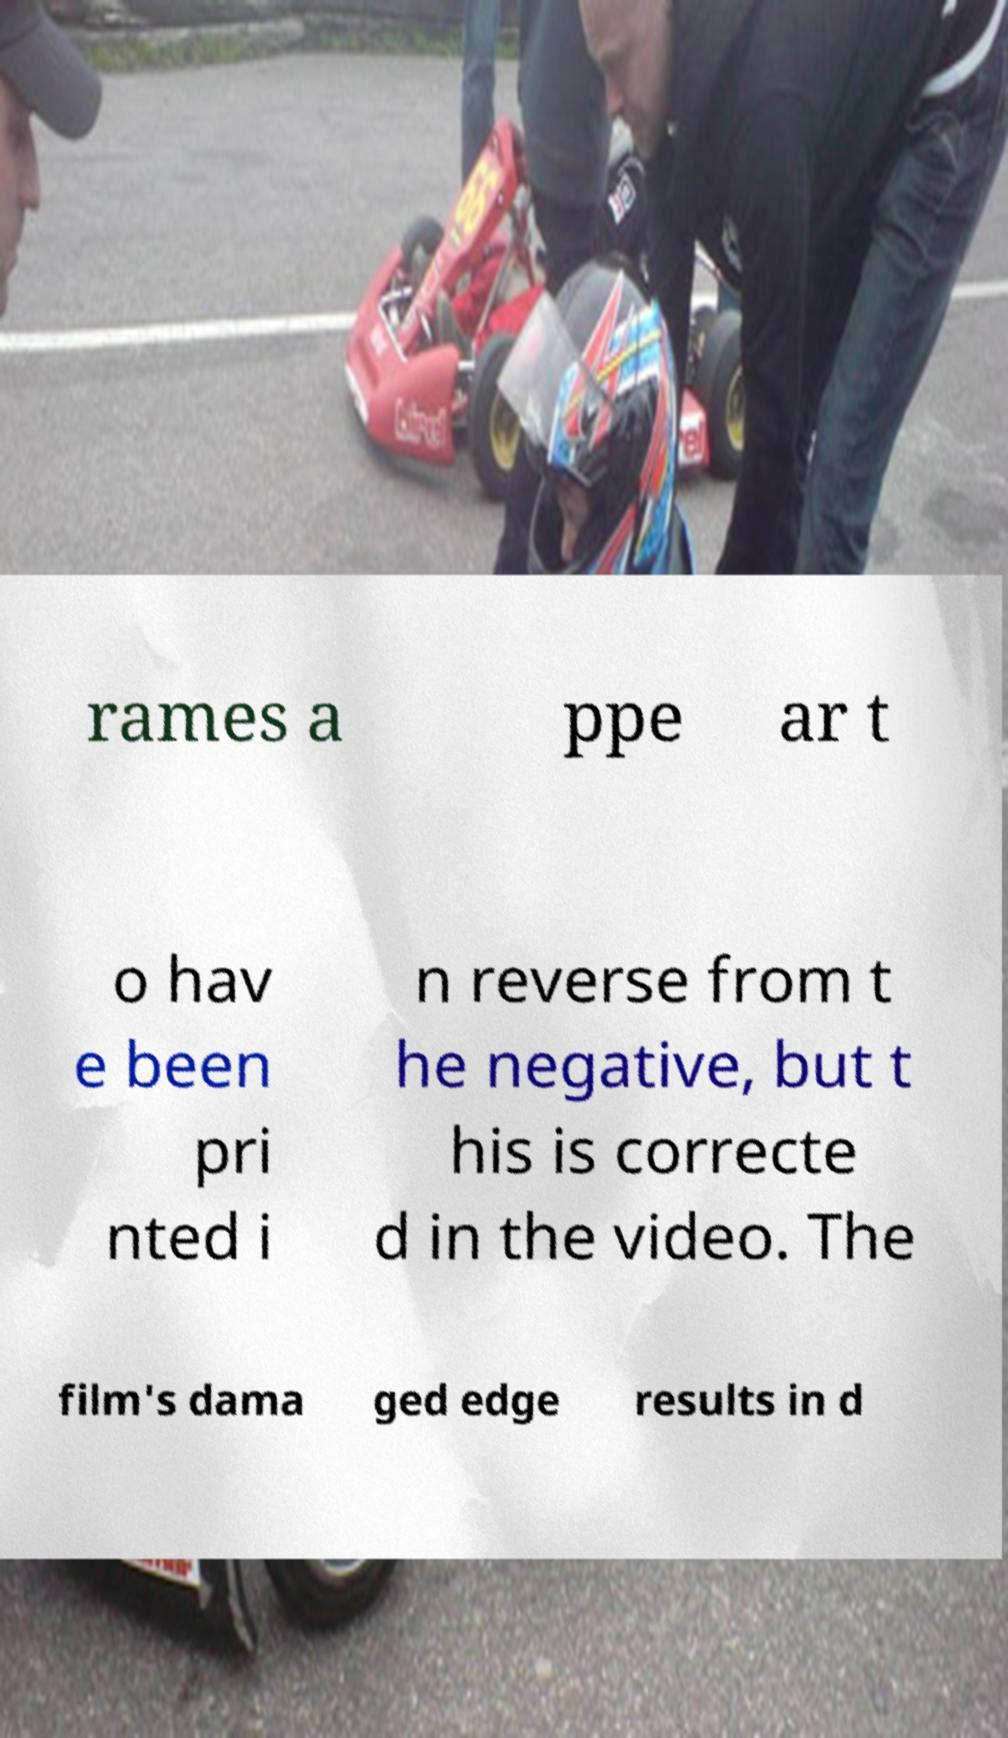There's text embedded in this image that I need extracted. Can you transcribe it verbatim? rames a ppe ar t o hav e been pri nted i n reverse from t he negative, but t his is correcte d in the video. The film's dama ged edge results in d 